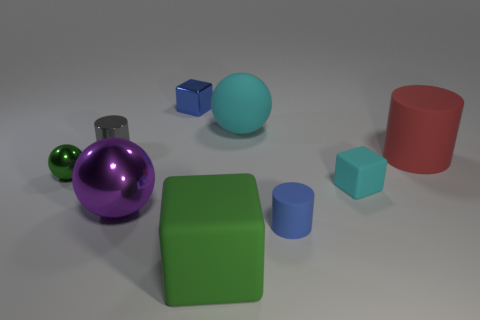Subtract all shiny spheres. How many spheres are left? 1 Add 1 red balls. How many objects exist? 10 Subtract all cyan matte cubes. Subtract all small green things. How many objects are left? 7 Add 6 big purple balls. How many big purple balls are left? 7 Add 4 large gray objects. How many large gray objects exist? 4 Subtract 1 purple spheres. How many objects are left? 8 Subtract all cylinders. How many objects are left? 6 